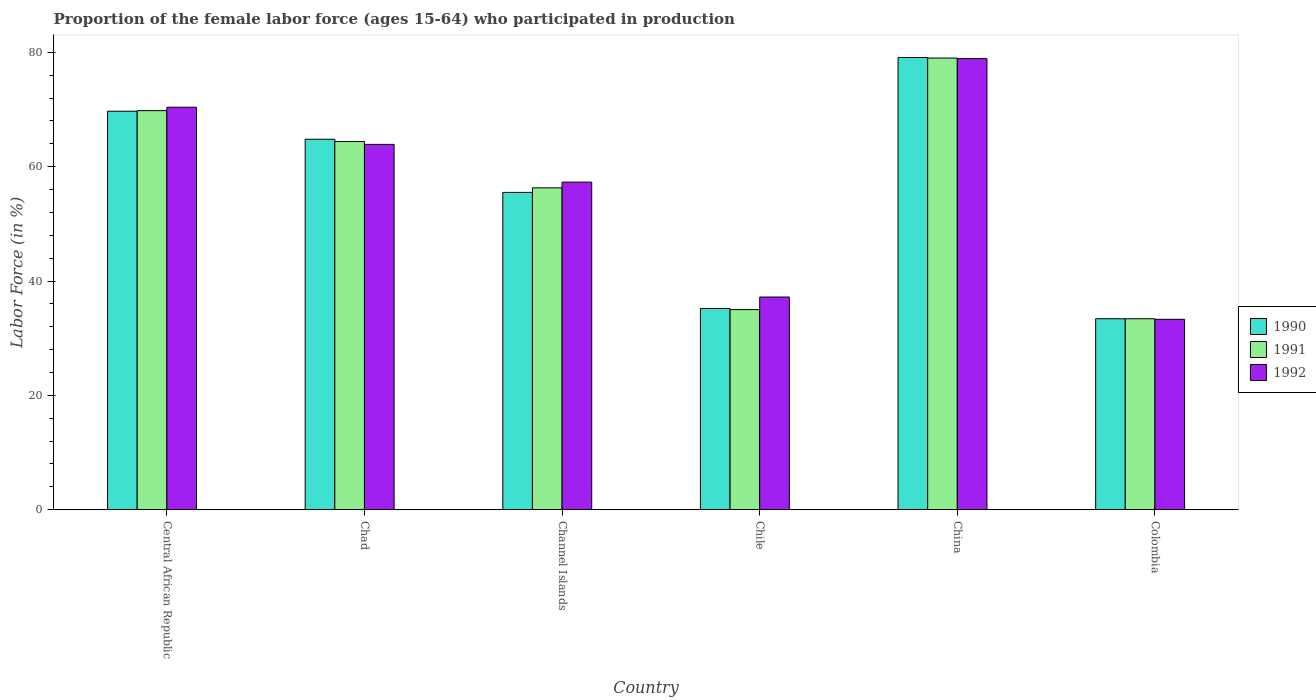How many different coloured bars are there?
Your answer should be compact. 3. How many groups of bars are there?
Offer a very short reply. 6. Are the number of bars per tick equal to the number of legend labels?
Your response must be concise. Yes. Are the number of bars on each tick of the X-axis equal?
Give a very brief answer. Yes. What is the proportion of the female labor force who participated in production in 1992 in Chad?
Provide a short and direct response. 63.9. Across all countries, what is the maximum proportion of the female labor force who participated in production in 1992?
Keep it short and to the point. 78.9. Across all countries, what is the minimum proportion of the female labor force who participated in production in 1992?
Give a very brief answer. 33.3. In which country was the proportion of the female labor force who participated in production in 1992 minimum?
Your answer should be very brief. Colombia. What is the total proportion of the female labor force who participated in production in 1992 in the graph?
Ensure brevity in your answer.  341. What is the difference between the proportion of the female labor force who participated in production in 1992 in Central African Republic and that in Colombia?
Your answer should be very brief. 37.1. What is the difference between the proportion of the female labor force who participated in production in 1990 in Channel Islands and the proportion of the female labor force who participated in production in 1992 in Colombia?
Keep it short and to the point. 22.2. What is the average proportion of the female labor force who participated in production in 1990 per country?
Your answer should be compact. 56.28. What is the difference between the proportion of the female labor force who participated in production of/in 1990 and proportion of the female labor force who participated in production of/in 1991 in Chile?
Your answer should be compact. 0.2. In how many countries, is the proportion of the female labor force who participated in production in 1991 greater than 52 %?
Your answer should be compact. 4. What is the ratio of the proportion of the female labor force who participated in production in 1990 in Chad to that in Chile?
Keep it short and to the point. 1.84. Is the proportion of the female labor force who participated in production in 1991 in Chad less than that in Chile?
Offer a terse response. No. Is the difference between the proportion of the female labor force who participated in production in 1990 in Chad and Channel Islands greater than the difference between the proportion of the female labor force who participated in production in 1991 in Chad and Channel Islands?
Provide a succinct answer. Yes. What is the difference between the highest and the second highest proportion of the female labor force who participated in production in 1991?
Give a very brief answer. -5.4. What is the difference between the highest and the lowest proportion of the female labor force who participated in production in 1991?
Provide a short and direct response. 45.6. How many bars are there?
Provide a short and direct response. 18. Are all the bars in the graph horizontal?
Your response must be concise. No. How many countries are there in the graph?
Provide a succinct answer. 6. What is the difference between two consecutive major ticks on the Y-axis?
Your answer should be very brief. 20. Are the values on the major ticks of Y-axis written in scientific E-notation?
Provide a short and direct response. No. Does the graph contain grids?
Ensure brevity in your answer.  No. Where does the legend appear in the graph?
Offer a very short reply. Center right. How are the legend labels stacked?
Offer a very short reply. Vertical. What is the title of the graph?
Keep it short and to the point. Proportion of the female labor force (ages 15-64) who participated in production. Does "1997" appear as one of the legend labels in the graph?
Keep it short and to the point. No. What is the Labor Force (in %) of 1990 in Central African Republic?
Make the answer very short. 69.7. What is the Labor Force (in %) of 1991 in Central African Republic?
Your answer should be very brief. 69.8. What is the Labor Force (in %) of 1992 in Central African Republic?
Give a very brief answer. 70.4. What is the Labor Force (in %) in 1990 in Chad?
Offer a very short reply. 64.8. What is the Labor Force (in %) of 1991 in Chad?
Your answer should be very brief. 64.4. What is the Labor Force (in %) of 1992 in Chad?
Keep it short and to the point. 63.9. What is the Labor Force (in %) in 1990 in Channel Islands?
Your answer should be compact. 55.5. What is the Labor Force (in %) in 1991 in Channel Islands?
Provide a short and direct response. 56.3. What is the Labor Force (in %) in 1992 in Channel Islands?
Provide a short and direct response. 57.3. What is the Labor Force (in %) of 1990 in Chile?
Offer a terse response. 35.2. What is the Labor Force (in %) in 1992 in Chile?
Your answer should be very brief. 37.2. What is the Labor Force (in %) of 1990 in China?
Offer a very short reply. 79.1. What is the Labor Force (in %) of 1991 in China?
Make the answer very short. 79. What is the Labor Force (in %) in 1992 in China?
Ensure brevity in your answer.  78.9. What is the Labor Force (in %) of 1990 in Colombia?
Give a very brief answer. 33.4. What is the Labor Force (in %) in 1991 in Colombia?
Make the answer very short. 33.4. What is the Labor Force (in %) in 1992 in Colombia?
Your answer should be very brief. 33.3. Across all countries, what is the maximum Labor Force (in %) of 1990?
Provide a short and direct response. 79.1. Across all countries, what is the maximum Labor Force (in %) in 1991?
Offer a very short reply. 79. Across all countries, what is the maximum Labor Force (in %) of 1992?
Keep it short and to the point. 78.9. Across all countries, what is the minimum Labor Force (in %) in 1990?
Provide a short and direct response. 33.4. Across all countries, what is the minimum Labor Force (in %) in 1991?
Offer a terse response. 33.4. Across all countries, what is the minimum Labor Force (in %) of 1992?
Offer a very short reply. 33.3. What is the total Labor Force (in %) in 1990 in the graph?
Your response must be concise. 337.7. What is the total Labor Force (in %) of 1991 in the graph?
Keep it short and to the point. 337.9. What is the total Labor Force (in %) of 1992 in the graph?
Give a very brief answer. 341. What is the difference between the Labor Force (in %) in 1992 in Central African Republic and that in Chad?
Your response must be concise. 6.5. What is the difference between the Labor Force (in %) in 1990 in Central African Republic and that in Channel Islands?
Make the answer very short. 14.2. What is the difference between the Labor Force (in %) in 1991 in Central African Republic and that in Channel Islands?
Provide a succinct answer. 13.5. What is the difference between the Labor Force (in %) of 1990 in Central African Republic and that in Chile?
Provide a succinct answer. 34.5. What is the difference between the Labor Force (in %) of 1991 in Central African Republic and that in Chile?
Your answer should be very brief. 34.8. What is the difference between the Labor Force (in %) in 1992 in Central African Republic and that in Chile?
Your answer should be very brief. 33.2. What is the difference between the Labor Force (in %) in 1990 in Central African Republic and that in China?
Provide a short and direct response. -9.4. What is the difference between the Labor Force (in %) of 1990 in Central African Republic and that in Colombia?
Offer a terse response. 36.3. What is the difference between the Labor Force (in %) in 1991 in Central African Republic and that in Colombia?
Your answer should be very brief. 36.4. What is the difference between the Labor Force (in %) in 1992 in Central African Republic and that in Colombia?
Offer a terse response. 37.1. What is the difference between the Labor Force (in %) in 1990 in Chad and that in Channel Islands?
Make the answer very short. 9.3. What is the difference between the Labor Force (in %) in 1990 in Chad and that in Chile?
Provide a succinct answer. 29.6. What is the difference between the Labor Force (in %) of 1991 in Chad and that in Chile?
Keep it short and to the point. 29.4. What is the difference between the Labor Force (in %) of 1992 in Chad and that in Chile?
Your answer should be very brief. 26.7. What is the difference between the Labor Force (in %) in 1990 in Chad and that in China?
Offer a very short reply. -14.3. What is the difference between the Labor Force (in %) in 1991 in Chad and that in China?
Provide a short and direct response. -14.6. What is the difference between the Labor Force (in %) in 1990 in Chad and that in Colombia?
Your response must be concise. 31.4. What is the difference between the Labor Force (in %) in 1991 in Chad and that in Colombia?
Offer a very short reply. 31. What is the difference between the Labor Force (in %) of 1992 in Chad and that in Colombia?
Offer a very short reply. 30.6. What is the difference between the Labor Force (in %) in 1990 in Channel Islands and that in Chile?
Your answer should be compact. 20.3. What is the difference between the Labor Force (in %) of 1991 in Channel Islands and that in Chile?
Give a very brief answer. 21.3. What is the difference between the Labor Force (in %) in 1992 in Channel Islands and that in Chile?
Ensure brevity in your answer.  20.1. What is the difference between the Labor Force (in %) in 1990 in Channel Islands and that in China?
Your response must be concise. -23.6. What is the difference between the Labor Force (in %) of 1991 in Channel Islands and that in China?
Make the answer very short. -22.7. What is the difference between the Labor Force (in %) in 1992 in Channel Islands and that in China?
Your answer should be very brief. -21.6. What is the difference between the Labor Force (in %) of 1990 in Channel Islands and that in Colombia?
Offer a very short reply. 22.1. What is the difference between the Labor Force (in %) of 1991 in Channel Islands and that in Colombia?
Provide a succinct answer. 22.9. What is the difference between the Labor Force (in %) in 1990 in Chile and that in China?
Provide a short and direct response. -43.9. What is the difference between the Labor Force (in %) of 1991 in Chile and that in China?
Offer a terse response. -44. What is the difference between the Labor Force (in %) in 1992 in Chile and that in China?
Offer a very short reply. -41.7. What is the difference between the Labor Force (in %) of 1990 in China and that in Colombia?
Provide a short and direct response. 45.7. What is the difference between the Labor Force (in %) of 1991 in China and that in Colombia?
Provide a succinct answer. 45.6. What is the difference between the Labor Force (in %) in 1992 in China and that in Colombia?
Give a very brief answer. 45.6. What is the difference between the Labor Force (in %) in 1990 in Central African Republic and the Labor Force (in %) in 1992 in Chad?
Make the answer very short. 5.8. What is the difference between the Labor Force (in %) of 1990 in Central African Republic and the Labor Force (in %) of 1991 in Channel Islands?
Ensure brevity in your answer.  13.4. What is the difference between the Labor Force (in %) in 1990 in Central African Republic and the Labor Force (in %) in 1991 in Chile?
Provide a succinct answer. 34.7. What is the difference between the Labor Force (in %) in 1990 in Central African Republic and the Labor Force (in %) in 1992 in Chile?
Provide a short and direct response. 32.5. What is the difference between the Labor Force (in %) of 1991 in Central African Republic and the Labor Force (in %) of 1992 in Chile?
Your answer should be compact. 32.6. What is the difference between the Labor Force (in %) of 1990 in Central African Republic and the Labor Force (in %) of 1991 in China?
Ensure brevity in your answer.  -9.3. What is the difference between the Labor Force (in %) of 1991 in Central African Republic and the Labor Force (in %) of 1992 in China?
Your response must be concise. -9.1. What is the difference between the Labor Force (in %) of 1990 in Central African Republic and the Labor Force (in %) of 1991 in Colombia?
Your answer should be very brief. 36.3. What is the difference between the Labor Force (in %) of 1990 in Central African Republic and the Labor Force (in %) of 1992 in Colombia?
Offer a terse response. 36.4. What is the difference between the Labor Force (in %) in 1991 in Central African Republic and the Labor Force (in %) in 1992 in Colombia?
Provide a succinct answer. 36.5. What is the difference between the Labor Force (in %) of 1990 in Chad and the Labor Force (in %) of 1991 in Channel Islands?
Provide a short and direct response. 8.5. What is the difference between the Labor Force (in %) of 1990 in Chad and the Labor Force (in %) of 1992 in Channel Islands?
Ensure brevity in your answer.  7.5. What is the difference between the Labor Force (in %) in 1990 in Chad and the Labor Force (in %) in 1991 in Chile?
Your answer should be compact. 29.8. What is the difference between the Labor Force (in %) of 1990 in Chad and the Labor Force (in %) of 1992 in Chile?
Keep it short and to the point. 27.6. What is the difference between the Labor Force (in %) of 1991 in Chad and the Labor Force (in %) of 1992 in Chile?
Give a very brief answer. 27.2. What is the difference between the Labor Force (in %) in 1990 in Chad and the Labor Force (in %) in 1991 in China?
Your answer should be very brief. -14.2. What is the difference between the Labor Force (in %) in 1990 in Chad and the Labor Force (in %) in 1992 in China?
Provide a succinct answer. -14.1. What is the difference between the Labor Force (in %) of 1990 in Chad and the Labor Force (in %) of 1991 in Colombia?
Make the answer very short. 31.4. What is the difference between the Labor Force (in %) of 1990 in Chad and the Labor Force (in %) of 1992 in Colombia?
Offer a very short reply. 31.5. What is the difference between the Labor Force (in %) in 1991 in Chad and the Labor Force (in %) in 1992 in Colombia?
Offer a terse response. 31.1. What is the difference between the Labor Force (in %) in 1990 in Channel Islands and the Labor Force (in %) in 1991 in Chile?
Make the answer very short. 20.5. What is the difference between the Labor Force (in %) of 1990 in Channel Islands and the Labor Force (in %) of 1992 in Chile?
Offer a very short reply. 18.3. What is the difference between the Labor Force (in %) in 1991 in Channel Islands and the Labor Force (in %) in 1992 in Chile?
Offer a very short reply. 19.1. What is the difference between the Labor Force (in %) of 1990 in Channel Islands and the Labor Force (in %) of 1991 in China?
Ensure brevity in your answer.  -23.5. What is the difference between the Labor Force (in %) in 1990 in Channel Islands and the Labor Force (in %) in 1992 in China?
Your answer should be very brief. -23.4. What is the difference between the Labor Force (in %) in 1991 in Channel Islands and the Labor Force (in %) in 1992 in China?
Your answer should be very brief. -22.6. What is the difference between the Labor Force (in %) of 1990 in Channel Islands and the Labor Force (in %) of 1991 in Colombia?
Your answer should be very brief. 22.1. What is the difference between the Labor Force (in %) in 1990 in Chile and the Labor Force (in %) in 1991 in China?
Your response must be concise. -43.8. What is the difference between the Labor Force (in %) of 1990 in Chile and the Labor Force (in %) of 1992 in China?
Keep it short and to the point. -43.7. What is the difference between the Labor Force (in %) in 1991 in Chile and the Labor Force (in %) in 1992 in China?
Make the answer very short. -43.9. What is the difference between the Labor Force (in %) in 1990 in China and the Labor Force (in %) in 1991 in Colombia?
Your answer should be very brief. 45.7. What is the difference between the Labor Force (in %) of 1990 in China and the Labor Force (in %) of 1992 in Colombia?
Provide a short and direct response. 45.8. What is the difference between the Labor Force (in %) of 1991 in China and the Labor Force (in %) of 1992 in Colombia?
Your answer should be compact. 45.7. What is the average Labor Force (in %) in 1990 per country?
Provide a short and direct response. 56.28. What is the average Labor Force (in %) of 1991 per country?
Provide a short and direct response. 56.32. What is the average Labor Force (in %) in 1992 per country?
Keep it short and to the point. 56.83. What is the difference between the Labor Force (in %) of 1990 and Labor Force (in %) of 1991 in Central African Republic?
Offer a terse response. -0.1. What is the difference between the Labor Force (in %) of 1990 and Labor Force (in %) of 1992 in Central African Republic?
Your answer should be very brief. -0.7. What is the difference between the Labor Force (in %) of 1990 and Labor Force (in %) of 1992 in Chad?
Ensure brevity in your answer.  0.9. What is the difference between the Labor Force (in %) of 1990 and Labor Force (in %) of 1991 in Chile?
Your answer should be very brief. 0.2. What is the difference between the Labor Force (in %) in 1990 and Labor Force (in %) in 1992 in Chile?
Provide a short and direct response. -2. What is the difference between the Labor Force (in %) in 1990 and Labor Force (in %) in 1991 in China?
Your answer should be very brief. 0.1. What is the difference between the Labor Force (in %) in 1990 and Labor Force (in %) in 1992 in China?
Make the answer very short. 0.2. What is the difference between the Labor Force (in %) of 1990 and Labor Force (in %) of 1991 in Colombia?
Provide a succinct answer. 0. What is the ratio of the Labor Force (in %) in 1990 in Central African Republic to that in Chad?
Make the answer very short. 1.08. What is the ratio of the Labor Force (in %) of 1991 in Central African Republic to that in Chad?
Provide a short and direct response. 1.08. What is the ratio of the Labor Force (in %) in 1992 in Central African Republic to that in Chad?
Ensure brevity in your answer.  1.1. What is the ratio of the Labor Force (in %) in 1990 in Central African Republic to that in Channel Islands?
Your answer should be very brief. 1.26. What is the ratio of the Labor Force (in %) in 1991 in Central African Republic to that in Channel Islands?
Your answer should be compact. 1.24. What is the ratio of the Labor Force (in %) of 1992 in Central African Republic to that in Channel Islands?
Offer a terse response. 1.23. What is the ratio of the Labor Force (in %) of 1990 in Central African Republic to that in Chile?
Provide a succinct answer. 1.98. What is the ratio of the Labor Force (in %) in 1991 in Central African Republic to that in Chile?
Provide a short and direct response. 1.99. What is the ratio of the Labor Force (in %) in 1992 in Central African Republic to that in Chile?
Offer a very short reply. 1.89. What is the ratio of the Labor Force (in %) in 1990 in Central African Republic to that in China?
Your answer should be very brief. 0.88. What is the ratio of the Labor Force (in %) in 1991 in Central African Republic to that in China?
Give a very brief answer. 0.88. What is the ratio of the Labor Force (in %) of 1992 in Central African Republic to that in China?
Ensure brevity in your answer.  0.89. What is the ratio of the Labor Force (in %) of 1990 in Central African Republic to that in Colombia?
Your response must be concise. 2.09. What is the ratio of the Labor Force (in %) of 1991 in Central African Republic to that in Colombia?
Offer a terse response. 2.09. What is the ratio of the Labor Force (in %) of 1992 in Central African Republic to that in Colombia?
Keep it short and to the point. 2.11. What is the ratio of the Labor Force (in %) in 1990 in Chad to that in Channel Islands?
Offer a very short reply. 1.17. What is the ratio of the Labor Force (in %) in 1991 in Chad to that in Channel Islands?
Your response must be concise. 1.14. What is the ratio of the Labor Force (in %) in 1992 in Chad to that in Channel Islands?
Give a very brief answer. 1.12. What is the ratio of the Labor Force (in %) of 1990 in Chad to that in Chile?
Your answer should be very brief. 1.84. What is the ratio of the Labor Force (in %) in 1991 in Chad to that in Chile?
Provide a succinct answer. 1.84. What is the ratio of the Labor Force (in %) in 1992 in Chad to that in Chile?
Make the answer very short. 1.72. What is the ratio of the Labor Force (in %) in 1990 in Chad to that in China?
Offer a very short reply. 0.82. What is the ratio of the Labor Force (in %) of 1991 in Chad to that in China?
Your response must be concise. 0.82. What is the ratio of the Labor Force (in %) in 1992 in Chad to that in China?
Your answer should be compact. 0.81. What is the ratio of the Labor Force (in %) of 1990 in Chad to that in Colombia?
Offer a terse response. 1.94. What is the ratio of the Labor Force (in %) of 1991 in Chad to that in Colombia?
Give a very brief answer. 1.93. What is the ratio of the Labor Force (in %) of 1992 in Chad to that in Colombia?
Your response must be concise. 1.92. What is the ratio of the Labor Force (in %) in 1990 in Channel Islands to that in Chile?
Your answer should be compact. 1.58. What is the ratio of the Labor Force (in %) in 1991 in Channel Islands to that in Chile?
Your answer should be very brief. 1.61. What is the ratio of the Labor Force (in %) in 1992 in Channel Islands to that in Chile?
Give a very brief answer. 1.54. What is the ratio of the Labor Force (in %) in 1990 in Channel Islands to that in China?
Offer a terse response. 0.7. What is the ratio of the Labor Force (in %) of 1991 in Channel Islands to that in China?
Your answer should be very brief. 0.71. What is the ratio of the Labor Force (in %) of 1992 in Channel Islands to that in China?
Your answer should be very brief. 0.73. What is the ratio of the Labor Force (in %) of 1990 in Channel Islands to that in Colombia?
Provide a succinct answer. 1.66. What is the ratio of the Labor Force (in %) of 1991 in Channel Islands to that in Colombia?
Ensure brevity in your answer.  1.69. What is the ratio of the Labor Force (in %) of 1992 in Channel Islands to that in Colombia?
Your response must be concise. 1.72. What is the ratio of the Labor Force (in %) in 1990 in Chile to that in China?
Ensure brevity in your answer.  0.45. What is the ratio of the Labor Force (in %) of 1991 in Chile to that in China?
Give a very brief answer. 0.44. What is the ratio of the Labor Force (in %) of 1992 in Chile to that in China?
Your response must be concise. 0.47. What is the ratio of the Labor Force (in %) of 1990 in Chile to that in Colombia?
Offer a very short reply. 1.05. What is the ratio of the Labor Force (in %) of 1991 in Chile to that in Colombia?
Make the answer very short. 1.05. What is the ratio of the Labor Force (in %) of 1992 in Chile to that in Colombia?
Give a very brief answer. 1.12. What is the ratio of the Labor Force (in %) in 1990 in China to that in Colombia?
Give a very brief answer. 2.37. What is the ratio of the Labor Force (in %) of 1991 in China to that in Colombia?
Your answer should be very brief. 2.37. What is the ratio of the Labor Force (in %) of 1992 in China to that in Colombia?
Offer a terse response. 2.37. What is the difference between the highest and the second highest Labor Force (in %) of 1990?
Provide a short and direct response. 9.4. What is the difference between the highest and the second highest Labor Force (in %) of 1992?
Your answer should be very brief. 8.5. What is the difference between the highest and the lowest Labor Force (in %) of 1990?
Offer a terse response. 45.7. What is the difference between the highest and the lowest Labor Force (in %) in 1991?
Give a very brief answer. 45.6. What is the difference between the highest and the lowest Labor Force (in %) of 1992?
Your answer should be very brief. 45.6. 